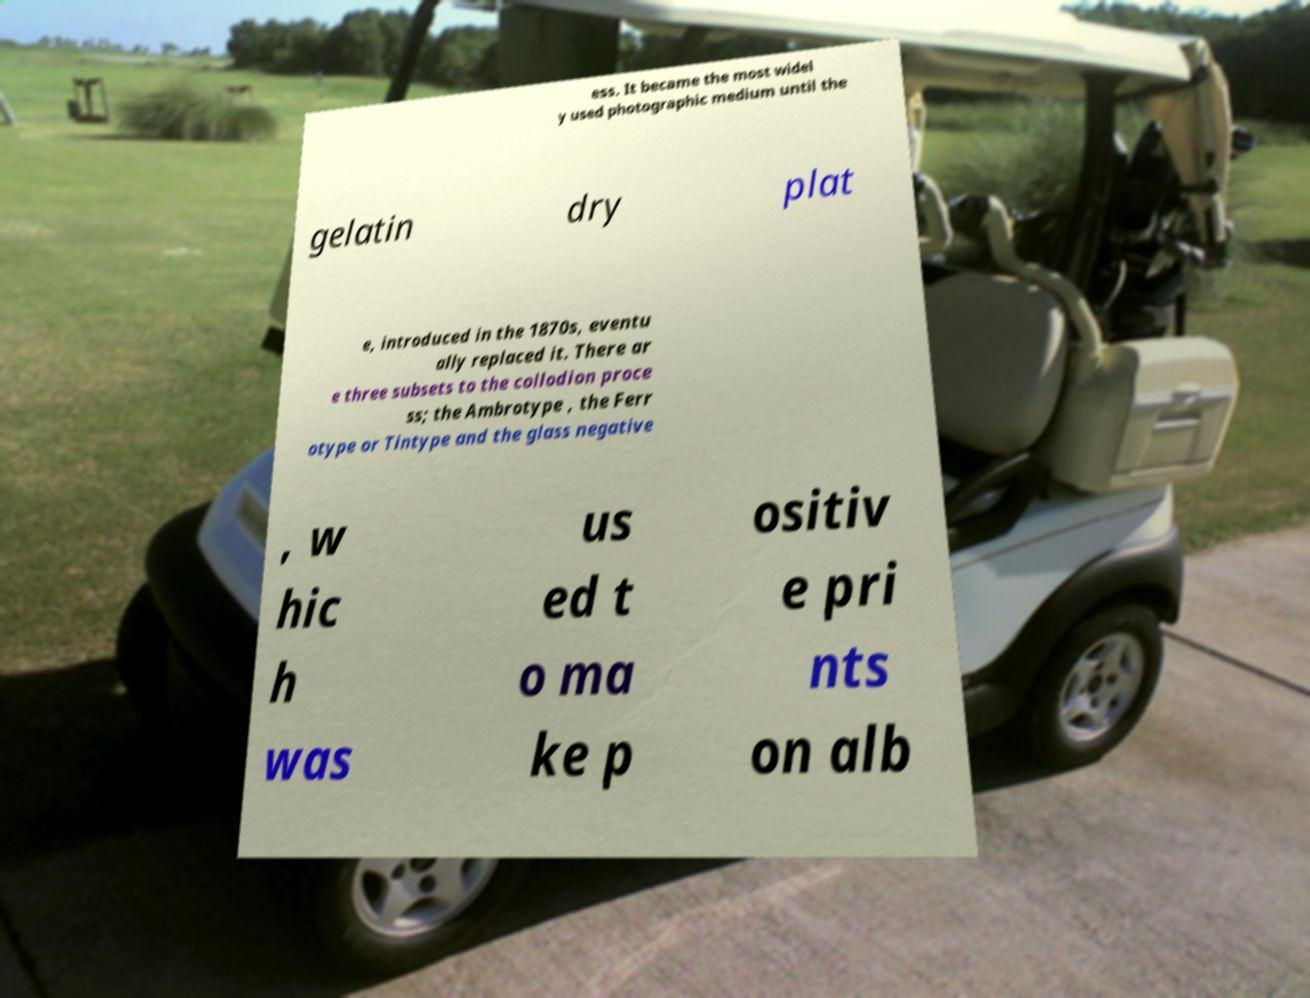What messages or text are displayed in this image? I need them in a readable, typed format. ess. It became the most widel y used photographic medium until the gelatin dry plat e, introduced in the 1870s, eventu ally replaced it. There ar e three subsets to the collodion proce ss; the Ambrotype , the Ferr otype or Tintype and the glass negative , w hic h was us ed t o ma ke p ositiv e pri nts on alb 